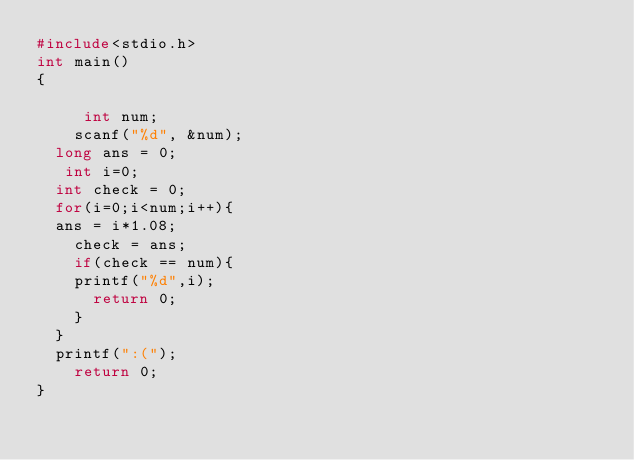<code> <loc_0><loc_0><loc_500><loc_500><_C_>#include<stdio.h>
int main()
{
   
     int num;
    scanf("%d", &num);
	long ans = 0;
   int i=0;
  int check = 0;
  for(i=0;i<num;i++){
	ans = i*1.08;
    check = ans;
  	if(check == num){
		printf("%d",i);
      return 0;
    }
  }
	printf(":(");
    return 0;
}</code> 